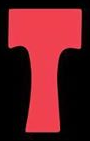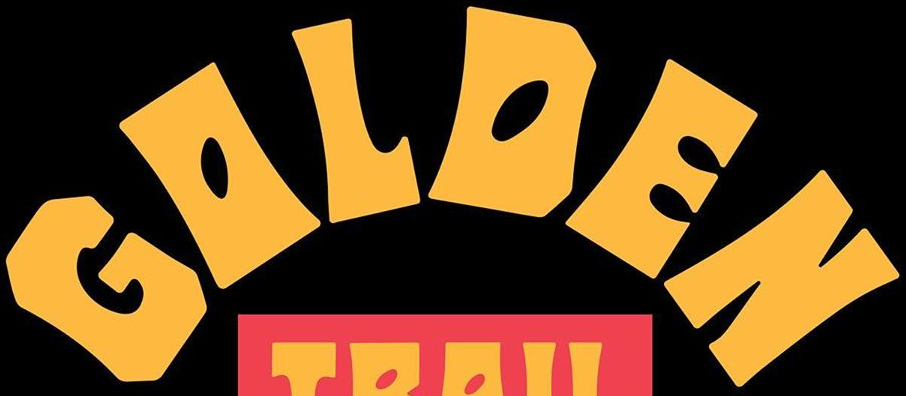Read the text content from these images in order, separated by a semicolon. T; GOLDEN 